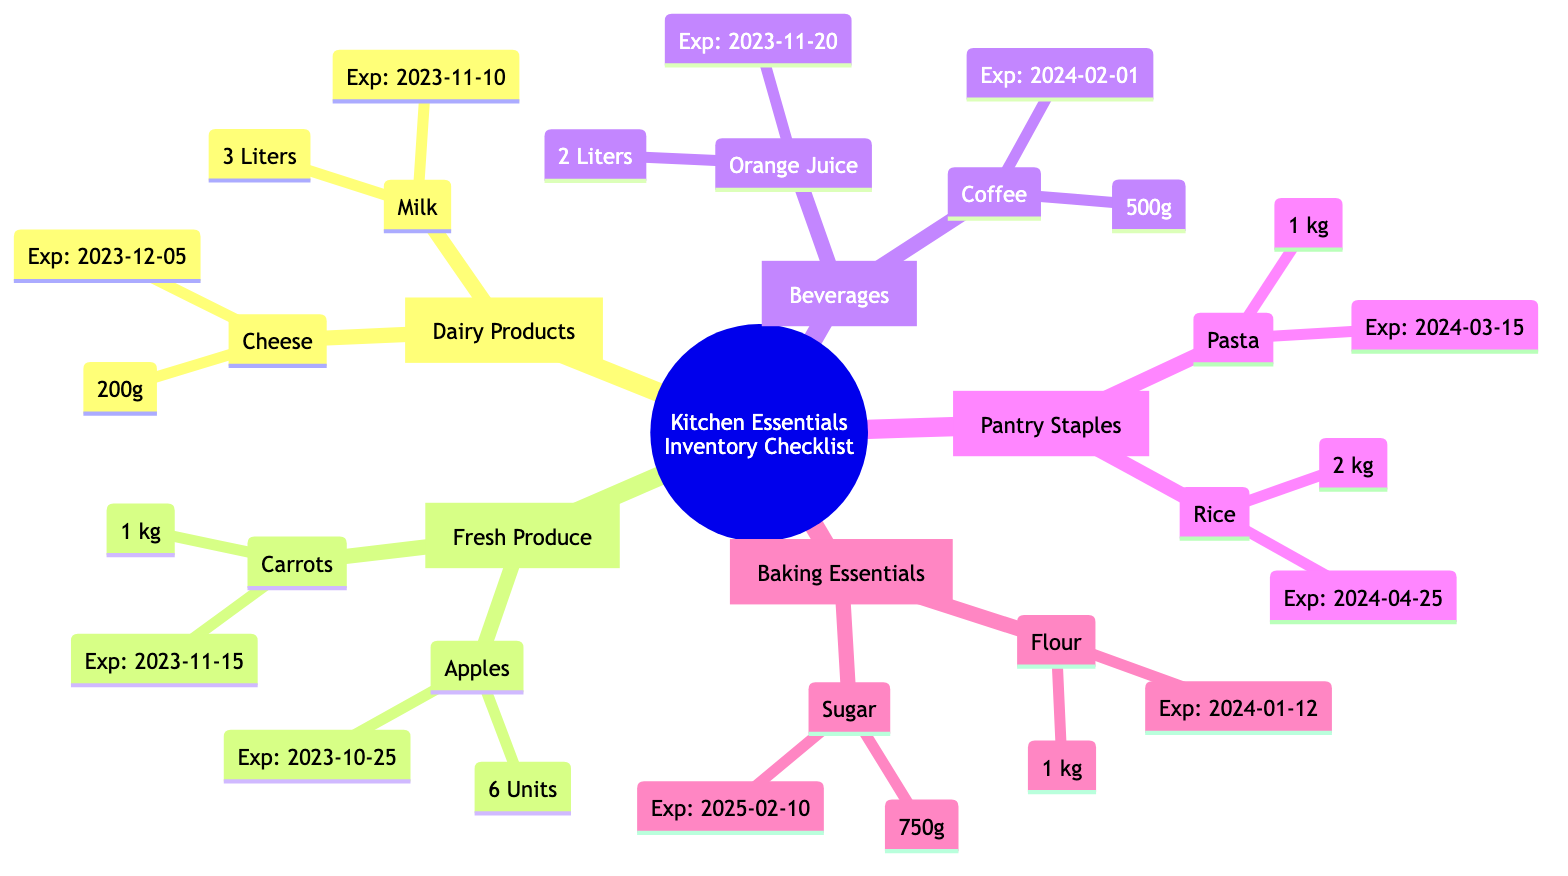What dairy product has the nearest expiry date? The dairy products listed are Milk, with an expiry date of 2023-11-10, and Cheese, which expires on 2023-12-05. Comparing these dates, Milk expires sooner.
Answer: Milk How many units of Apples are listed in the inventory? In the Fresh Produce section, the inventory shows 6 Units of Apples. Therefore, the quantity provided is directly taken from that listing.
Answer: 6 Units What is the expiry date of the Coffee? The Coffee listed in the Beverages section has an expiry date of 2024-02-01, which is indicated next to its quantity in the diagram.
Answer: 2024-02-01 Which has a longer shelf life, Sugar or Carrots? Sugar expires on 2025-02-10, while Carrots have an expiry date of 2023-11-15. By comparing these two dates, we find that Sugar lasts significantly longer.
Answer: Sugar What is the total amount of Rice and Pasta combined? Rice is listed at 2 kg and Pasta at 1 kg. Combining these quantities gives 2 kg + 1 kg = 3 kg total for these two pantry staples.
Answer: 3 kg How many categories are present in the inventory? The diagram lists five distinct categories: Dairy Products, Fresh Produce, Beverages, Pantry Staples, and Baking Essentials. Counting these gives a total of 5 categories.
Answer: 5 Which product from the Baking Essentials expires first? In the Baking Essentials section, Flour has an expiry date of 2024-01-12, and Sugar expires later on 2025-02-10. Here, Flour is the product that expires first.
Answer: Flour What is the total weight of the Dairy Products listed? The Dairy Products listed include Milk (3 Liters, typically not counted as weight) and Cheese (200g). The Cheese contributes a total weight of 200g, while Milk's weight is generally measured in liquid volume; hence only the cheese is considered.
Answer: 200g 